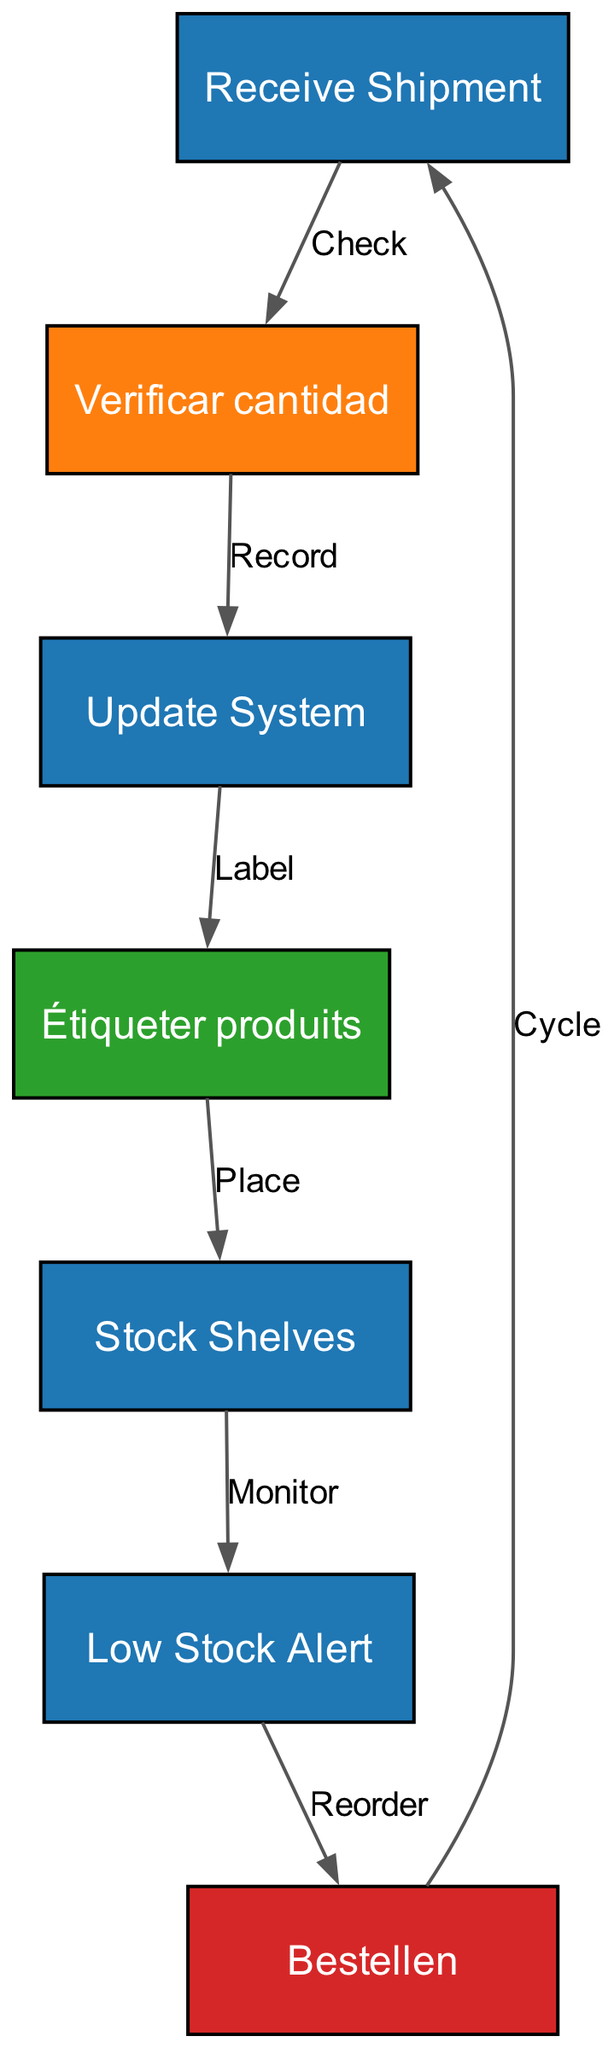What is the first step in the inventory management flowchart? The first step is labeled "Receive Shipment," which is represented as node 1 in the diagram.
Answer: Receive Shipment How many nodes are present in the flowchart? By counting the nodes listed in the data, there are a total of 7 nodes in the flowchart.
Answer: 7 What color represents Spanish in the flowchart? The color representing Spanish is orange, as indicated in the color scheme provided in the diagram.
Answer: Orange What is the relationship between "Stock Shelves" and "Low Stock Alert"? The relationship is identified by the edge connecting these two nodes, which indicates a monitoring action after shelving the stock.
Answer: Monitor Which language is used for the node labeled "Étiqueter produits"? The node "Étiqueter produits" is in French, as specified in the node data for this label.
Answer: French What action follows the "Low Stock Alert"? The action that follows "Low Stock Alert" is "Bestellen," which indicates a reorder action according to the diagram's flow.
Answer: Reorder How many edges connect the various nodes in the diagram? There are a total of 6 edges connecting the nodes, illustrating the flow of actions in the inventory management process.
Answer: 6 What is the last node in the flow and where does it connect back to? The last node in the flow is "Bestellen," which connects back to "Receive Shipment," thereby indicating a cycle in the inventory process.
Answer: Receive Shipment What is the label that comes after "Verificar cantidad"? The label that comes after "Verificar cantidad" is "Update System," represented by node 3 in the diagram, which signifies the next step in the process.
Answer: Update System 